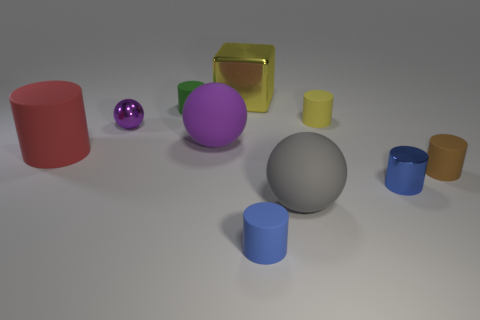Is there anything else that is the same shape as the large yellow metal thing?
Give a very brief answer. No. Is the number of big matte cylinders that are behind the brown rubber cylinder greater than the number of yellow shiny objects that are in front of the big yellow shiny object?
Offer a terse response. Yes. What is the material of the big cube?
Your answer should be compact. Metal. Are there any gray spheres of the same size as the blue metallic thing?
Give a very brief answer. No. What material is the green cylinder that is the same size as the blue rubber cylinder?
Offer a very short reply. Rubber. What number of large things are there?
Provide a succinct answer. 4. There is a rubber ball that is in front of the blue shiny thing; how big is it?
Your answer should be very brief. Large. Is the number of metal blocks that are to the left of the purple rubber object the same as the number of blue matte things?
Provide a succinct answer. No. Is there a small brown matte object of the same shape as the tiny blue matte object?
Offer a very short reply. Yes. There is a tiny thing that is on the left side of the brown rubber object and right of the yellow matte object; what is its shape?
Offer a terse response. Cylinder. 